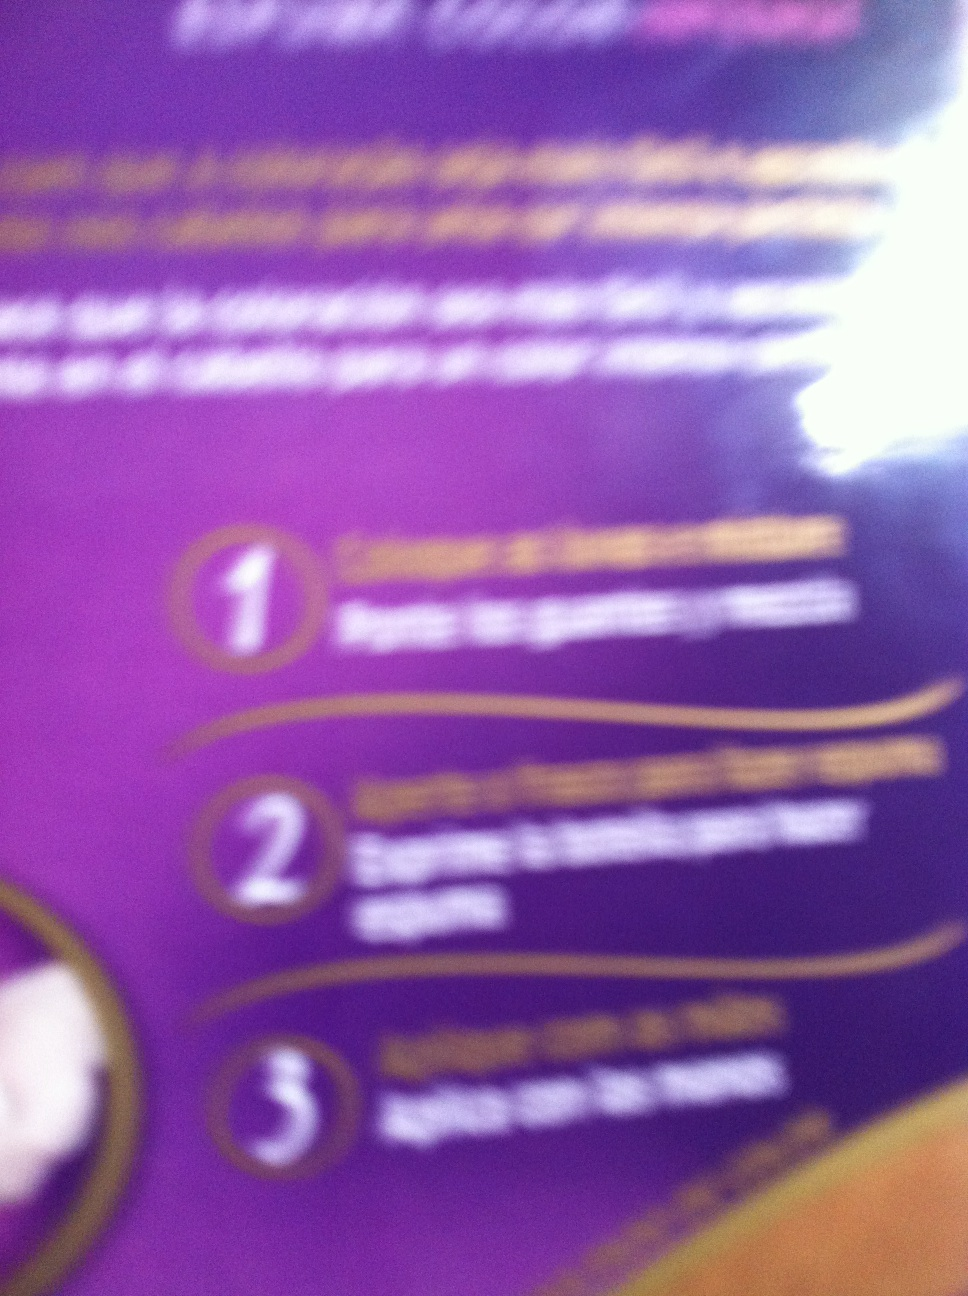How should I use this product please? Thank you. To use this product, please follow these steps:

1. Apply generously to the desired area.
2. Ensure it is evenly spread for full coverage.
3. Allow it to absorb completely for best results. 